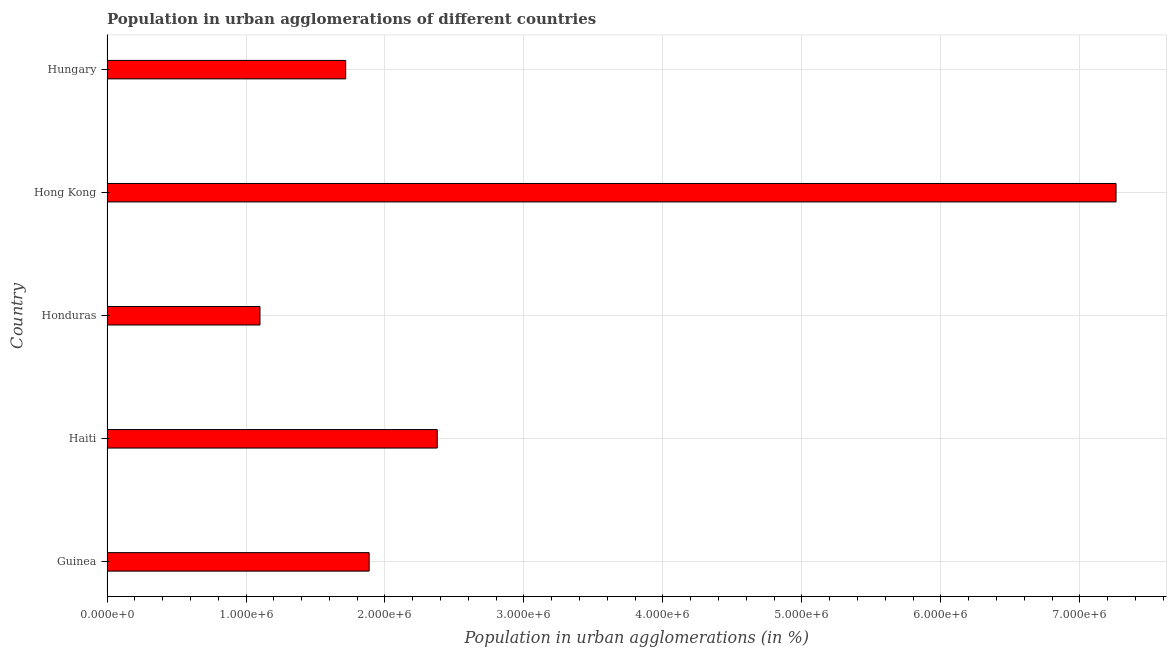Does the graph contain any zero values?
Offer a very short reply. No. Does the graph contain grids?
Keep it short and to the point. Yes. What is the title of the graph?
Give a very brief answer. Population in urban agglomerations of different countries. What is the label or title of the X-axis?
Offer a very short reply. Population in urban agglomerations (in %). What is the population in urban agglomerations in Guinea?
Provide a short and direct response. 1.89e+06. Across all countries, what is the maximum population in urban agglomerations?
Give a very brief answer. 7.26e+06. Across all countries, what is the minimum population in urban agglomerations?
Provide a succinct answer. 1.10e+06. In which country was the population in urban agglomerations maximum?
Provide a succinct answer. Hong Kong. In which country was the population in urban agglomerations minimum?
Provide a succinct answer. Honduras. What is the sum of the population in urban agglomerations?
Offer a very short reply. 1.43e+07. What is the difference between the population in urban agglomerations in Honduras and Hungary?
Provide a succinct answer. -6.17e+05. What is the average population in urban agglomerations per country?
Offer a terse response. 2.87e+06. What is the median population in urban agglomerations?
Provide a succinct answer. 1.89e+06. In how many countries, is the population in urban agglomerations greater than 6400000 %?
Offer a terse response. 1. What is the ratio of the population in urban agglomerations in Honduras to that in Hungary?
Offer a terse response. 0.64. Is the difference between the population in urban agglomerations in Haiti and Hong Kong greater than the difference between any two countries?
Your answer should be compact. No. What is the difference between the highest and the second highest population in urban agglomerations?
Your answer should be compact. 4.88e+06. What is the difference between the highest and the lowest population in urban agglomerations?
Keep it short and to the point. 6.16e+06. How many bars are there?
Make the answer very short. 5. Are all the bars in the graph horizontal?
Provide a short and direct response. Yes. How many countries are there in the graph?
Offer a terse response. 5. What is the difference between two consecutive major ticks on the X-axis?
Your answer should be very brief. 1.00e+06. What is the Population in urban agglomerations (in %) of Guinea?
Give a very brief answer. 1.89e+06. What is the Population in urban agglomerations (in %) in Haiti?
Your answer should be very brief. 2.38e+06. What is the Population in urban agglomerations (in %) in Honduras?
Ensure brevity in your answer.  1.10e+06. What is the Population in urban agglomerations (in %) in Hong Kong?
Provide a succinct answer. 7.26e+06. What is the Population in urban agglomerations (in %) in Hungary?
Ensure brevity in your answer.  1.72e+06. What is the difference between the Population in urban agglomerations (in %) in Guinea and Haiti?
Give a very brief answer. -4.90e+05. What is the difference between the Population in urban agglomerations (in %) in Guinea and Honduras?
Offer a terse response. 7.85e+05. What is the difference between the Population in urban agglomerations (in %) in Guinea and Hong Kong?
Make the answer very short. -5.37e+06. What is the difference between the Population in urban agglomerations (in %) in Guinea and Hungary?
Your answer should be very brief. 1.69e+05. What is the difference between the Population in urban agglomerations (in %) in Haiti and Honduras?
Offer a terse response. 1.28e+06. What is the difference between the Population in urban agglomerations (in %) in Haiti and Hong Kong?
Your answer should be very brief. -4.88e+06. What is the difference between the Population in urban agglomerations (in %) in Haiti and Hungary?
Offer a very short reply. 6.59e+05. What is the difference between the Population in urban agglomerations (in %) in Honduras and Hong Kong?
Your response must be concise. -6.16e+06. What is the difference between the Population in urban agglomerations (in %) in Honduras and Hungary?
Your response must be concise. -6.17e+05. What is the difference between the Population in urban agglomerations (in %) in Hong Kong and Hungary?
Ensure brevity in your answer.  5.54e+06. What is the ratio of the Population in urban agglomerations (in %) in Guinea to that in Haiti?
Provide a short and direct response. 0.79. What is the ratio of the Population in urban agglomerations (in %) in Guinea to that in Honduras?
Keep it short and to the point. 1.71. What is the ratio of the Population in urban agglomerations (in %) in Guinea to that in Hong Kong?
Ensure brevity in your answer.  0.26. What is the ratio of the Population in urban agglomerations (in %) in Guinea to that in Hungary?
Give a very brief answer. 1.1. What is the ratio of the Population in urban agglomerations (in %) in Haiti to that in Honduras?
Provide a succinct answer. 2.16. What is the ratio of the Population in urban agglomerations (in %) in Haiti to that in Hong Kong?
Give a very brief answer. 0.33. What is the ratio of the Population in urban agglomerations (in %) in Haiti to that in Hungary?
Keep it short and to the point. 1.38. What is the ratio of the Population in urban agglomerations (in %) in Honduras to that in Hong Kong?
Offer a very short reply. 0.15. What is the ratio of the Population in urban agglomerations (in %) in Honduras to that in Hungary?
Offer a very short reply. 0.64. What is the ratio of the Population in urban agglomerations (in %) in Hong Kong to that in Hungary?
Your answer should be very brief. 4.23. 